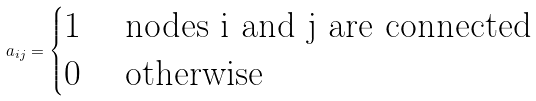Convert formula to latex. <formula><loc_0><loc_0><loc_500><loc_500>a _ { i j } = \begin{cases} 1 & \text { nodes i and j are connected} \\ 0 & \text { otherwise} \end{cases}</formula> 